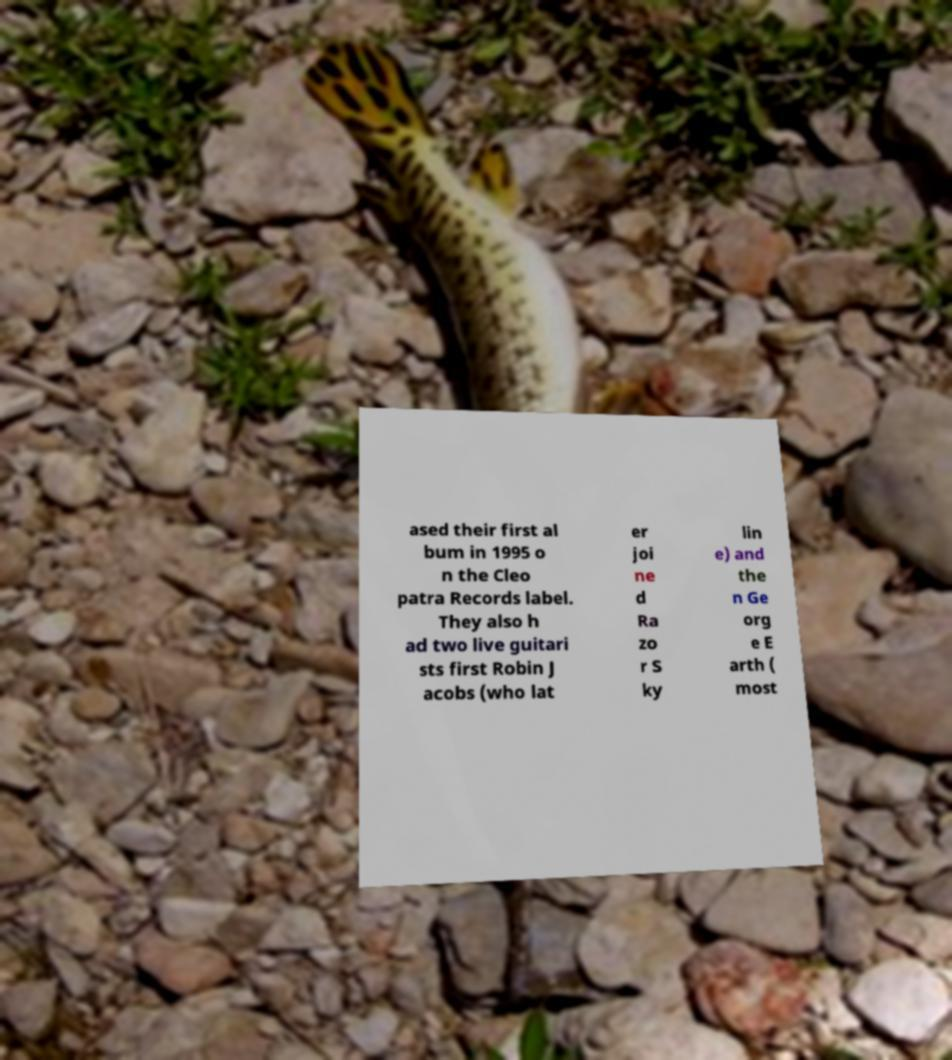I need the written content from this picture converted into text. Can you do that? ased their first al bum in 1995 o n the Cleo patra Records label. They also h ad two live guitari sts first Robin J acobs (who lat er joi ne d Ra zo r S ky lin e) and the n Ge org e E arth ( most 